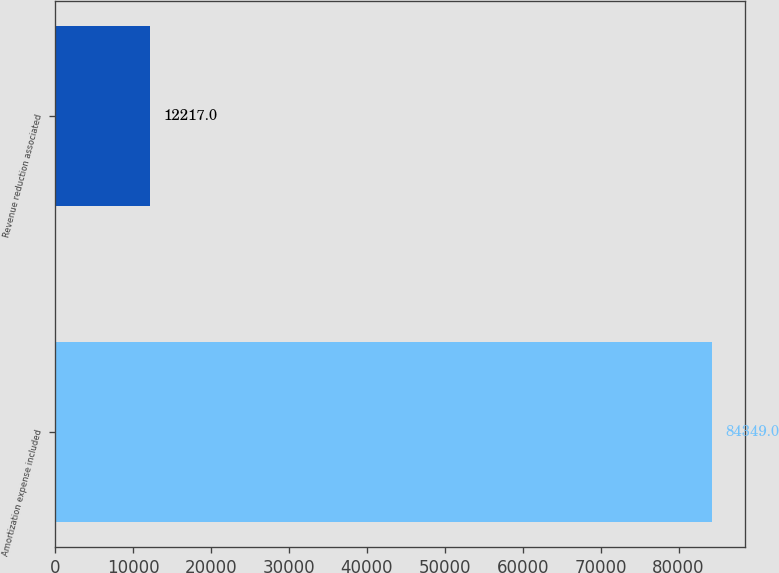<chart> <loc_0><loc_0><loc_500><loc_500><bar_chart><fcel>Amortization expense included<fcel>Revenue reduction associated<nl><fcel>84349<fcel>12217<nl></chart> 